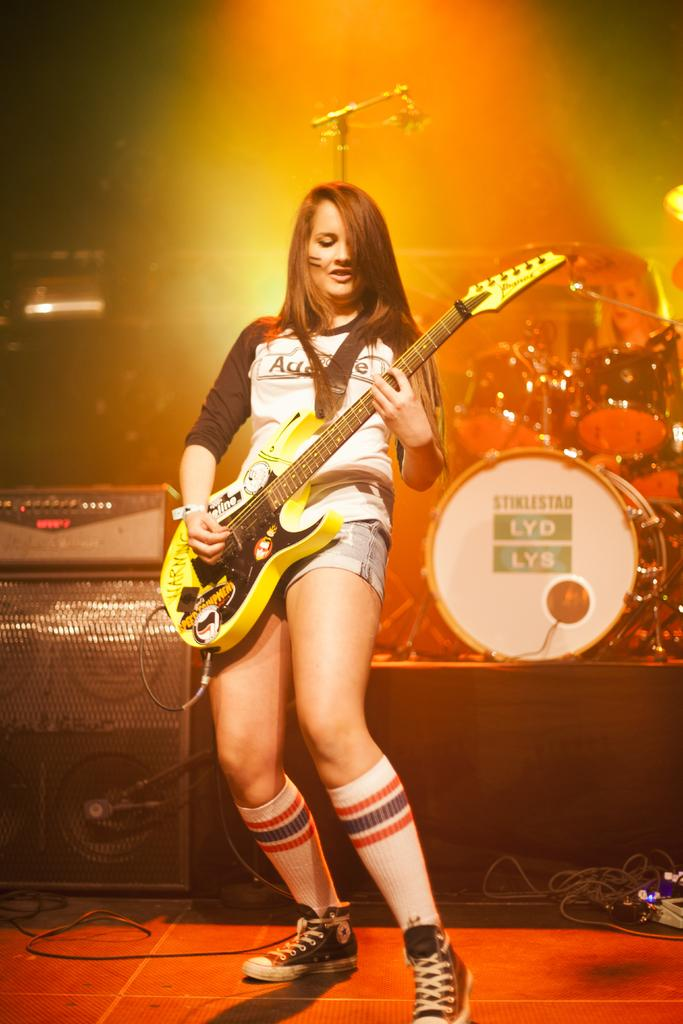Who is the main subject in the image? There is a woman in the image. What is the woman doing in the image? The woman is standing and playing a guitar. What other musical instruments can be seen in the background of the image? There are drums in the background of the image. What equipment is present for amplifying sound and vocals? There is a microphone and a speaker in the background of the image. What type of cup is being used to collect lava from the volcano in the image? There is no cup or volcano present in the image; it features a woman playing a guitar and musical equipment in the background. 